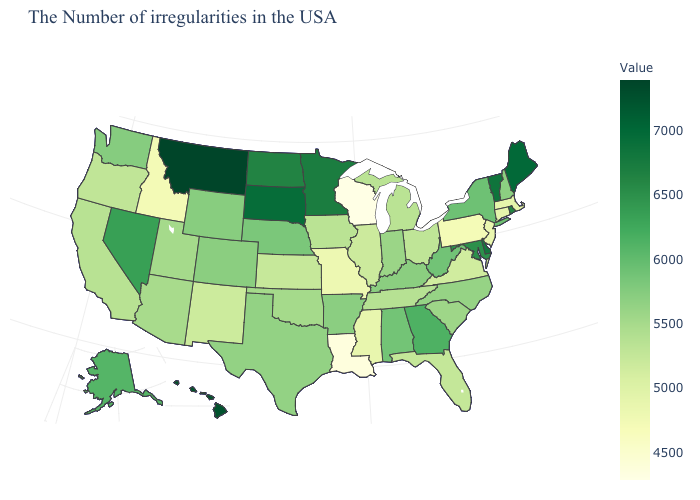Is the legend a continuous bar?
Keep it brief. Yes. Does Alaska have the highest value in the USA?
Quick response, please. No. Which states have the lowest value in the USA?
Quick response, please. Wisconsin. Among the states that border Georgia , which have the lowest value?
Short answer required. Florida. 